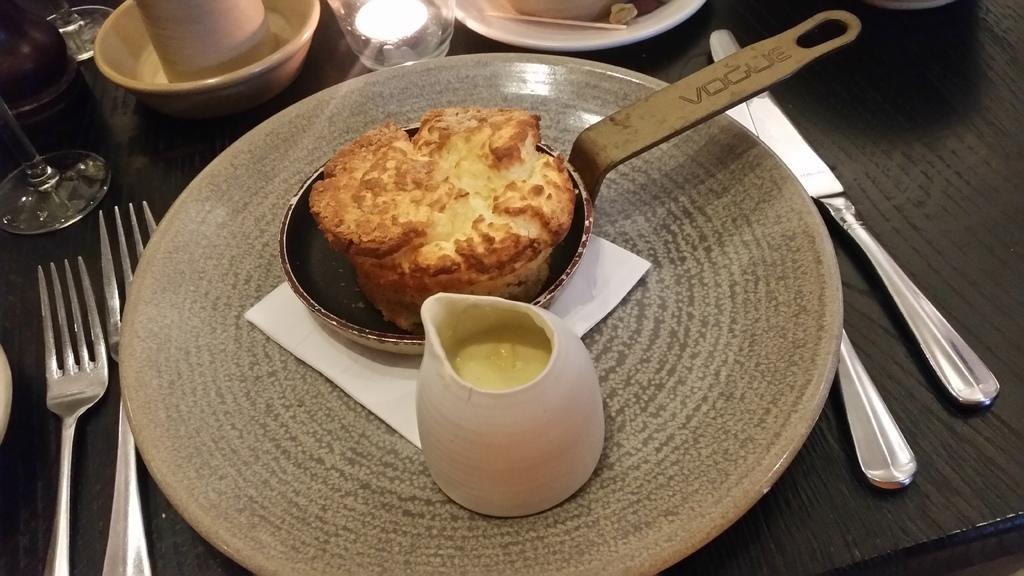Can you describe this image briefly? On this table there is a knife, forks, glasses, bowl, plates, food and things. 